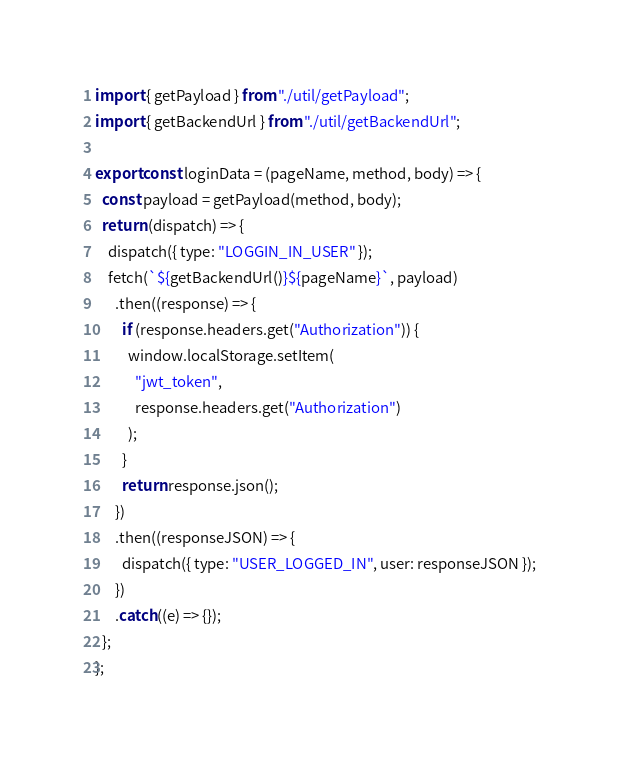Convert code to text. <code><loc_0><loc_0><loc_500><loc_500><_JavaScript_>import { getPayload } from "./util/getPayload";
import { getBackendUrl } from "./util/getBackendUrl";

export const loginData = (pageName, method, body) => {
  const payload = getPayload(method, body);
  return (dispatch) => {
    dispatch({ type: "LOGGIN_IN_USER" });
    fetch(`${getBackendUrl()}${pageName}`, payload)
      .then((response) => {
        if (response.headers.get("Authorization")) {
          window.localStorage.setItem(
            "jwt_token",
            response.headers.get("Authorization")
          );
        }
        return response.json();
      })
      .then((responseJSON) => {
        dispatch({ type: "USER_LOGGED_IN", user: responseJSON });
      })
      .catch((e) => {});
  };
};
</code> 